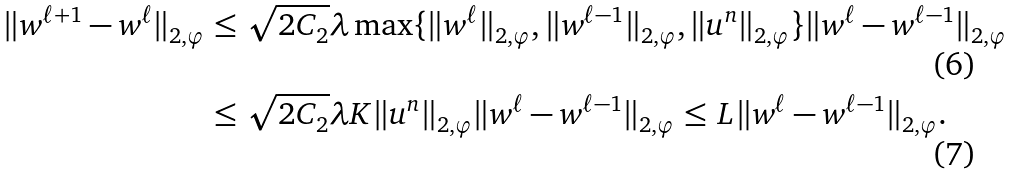<formula> <loc_0><loc_0><loc_500><loc_500>\| w ^ { \ell + 1 } - w ^ { \ell } \| _ { 2 , \varphi } & \leq \sqrt { 2 C _ { 2 } } \lambda \max \{ \| w ^ { \ell } \| _ { 2 , \varphi } , \| w ^ { \ell - 1 } \| _ { 2 , \varphi } , \| u ^ { n } \| _ { 2 , \varphi } \} \| w ^ { \ell } - w ^ { \ell - 1 } \| _ { 2 , \varphi } \\ & \leq \sqrt { 2 C _ { 2 } } \lambda K \| u ^ { n } \| _ { 2 , \varphi } \| w ^ { \ell } - w ^ { \ell - 1 } \| _ { 2 , \varphi } \leq L \| w ^ { \ell } - w ^ { \ell - 1 } \| _ { 2 , \varphi } .</formula> 